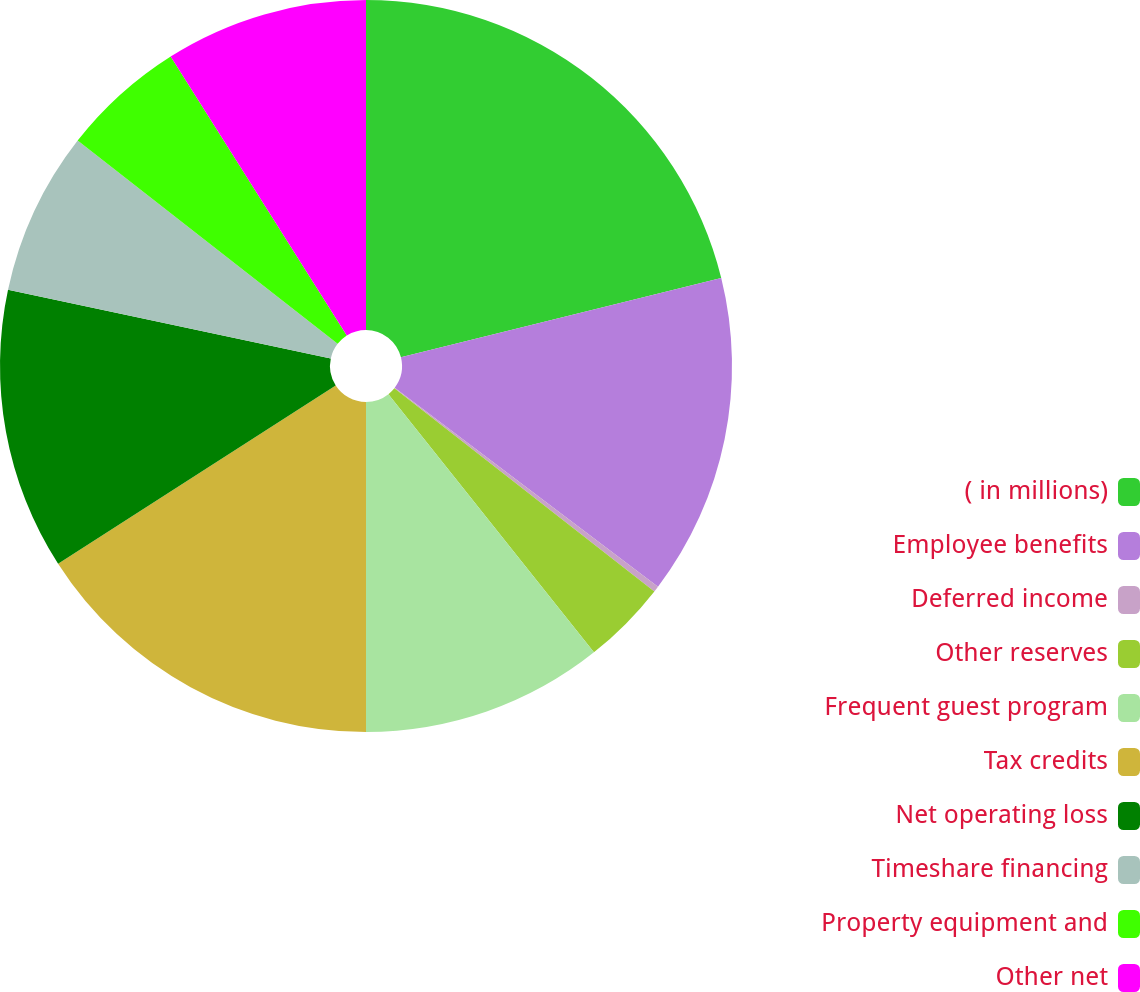Convert chart. <chart><loc_0><loc_0><loc_500><loc_500><pie_chart><fcel>( in millions)<fcel>Employee benefits<fcel>Deferred income<fcel>Other reserves<fcel>Frequent guest program<fcel>Tax credits<fcel>Net operating loss<fcel>Timeshare financing<fcel>Property equipment and<fcel>Other net<nl><fcel>21.13%<fcel>14.17%<fcel>0.26%<fcel>3.74%<fcel>10.7%<fcel>15.91%<fcel>12.43%<fcel>7.22%<fcel>5.48%<fcel>8.96%<nl></chart> 